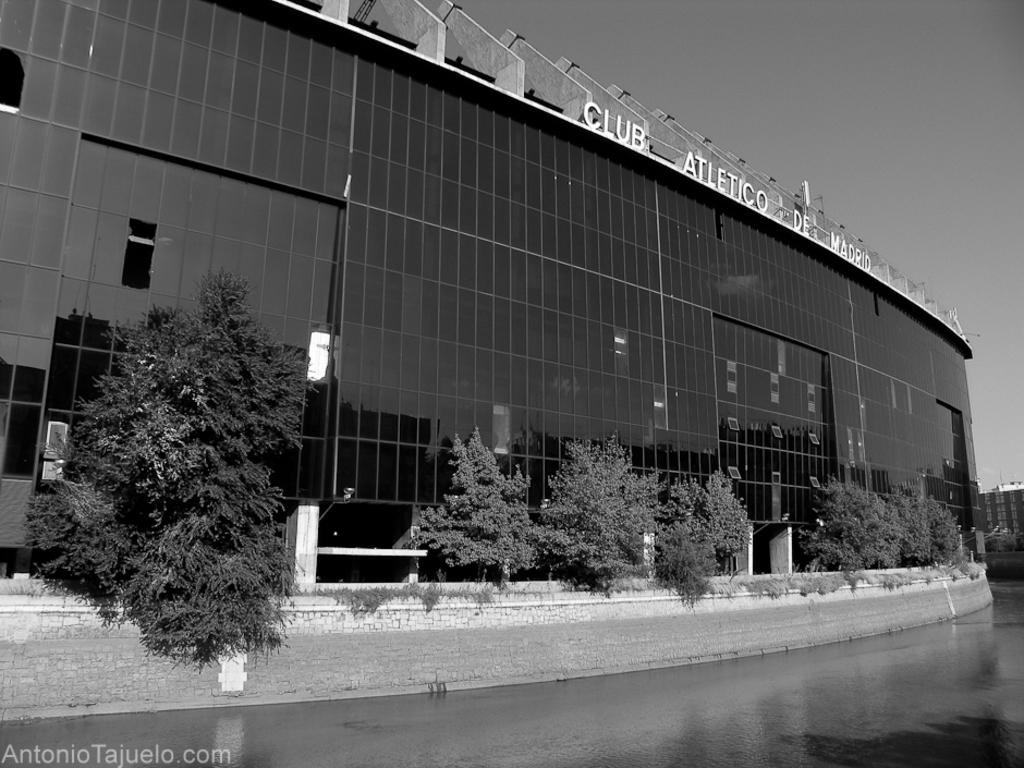What type of building is shown in the image? There is a large building with glass in the image. What other elements can be seen in the image besides the building? There are trees and water visible in the image. Are there any other buildings in the image? Yes, there is another building on the right side of the image. How does the cake compare to the oatmeal in the image? There is no cake or oatmeal present in the image. 